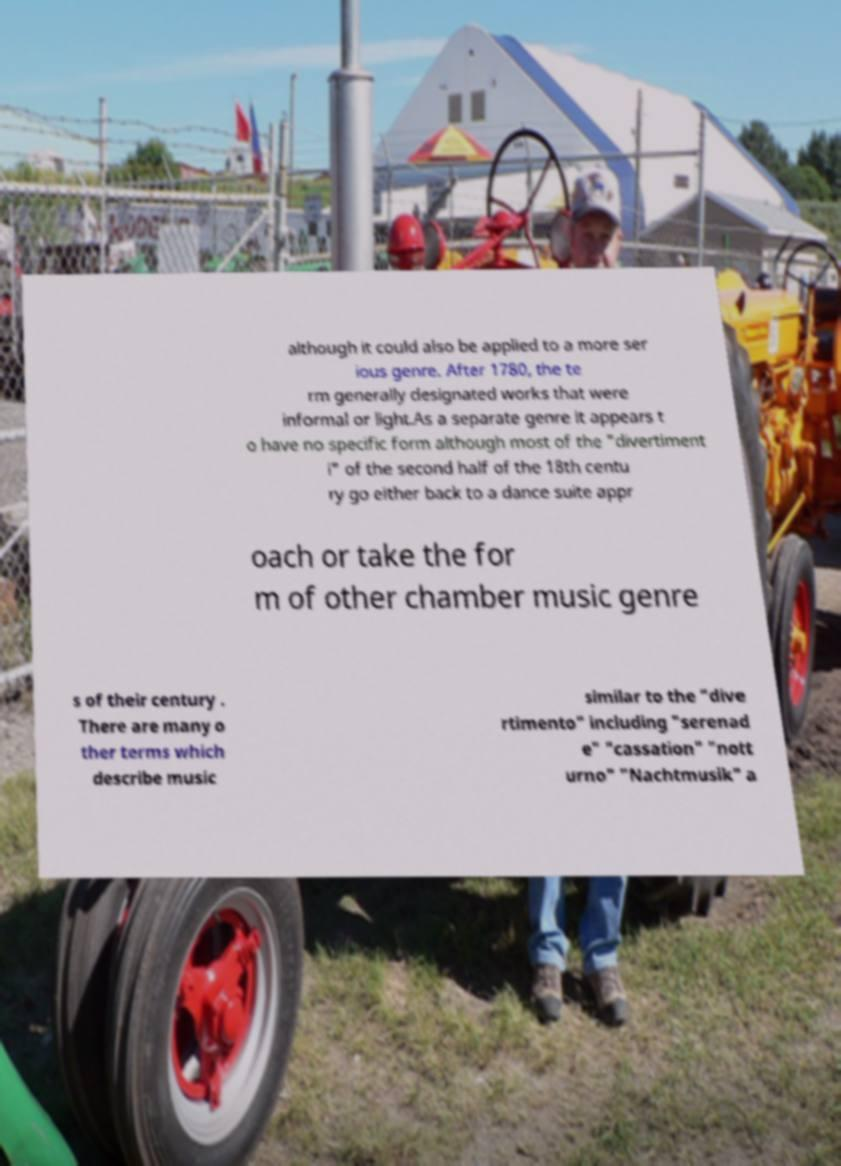For documentation purposes, I need the text within this image transcribed. Could you provide that? although it could also be applied to a more ser ious genre. After 1780, the te rm generally designated works that were informal or light.As a separate genre it appears t o have no specific form although most of the "divertiment i" of the second half of the 18th centu ry go either back to a dance suite appr oach or take the for m of other chamber music genre s of their century . There are many o ther terms which describe music similar to the "dive rtimento" including "serenad e" "cassation" "nott urno" "Nachtmusik" a 